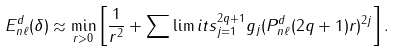<formula> <loc_0><loc_0><loc_500><loc_500>E _ { n \ell } ^ { d } ( \delta ) \approx \min _ { r > 0 } \left [ \frac { 1 } { r ^ { 2 } } + \sum \lim i t s _ { j = 1 } ^ { 2 q + 1 } g _ { j } ( P _ { n \ell } ^ { d } ( 2 q + 1 ) r ) ^ { 2 j } \right ] .</formula> 